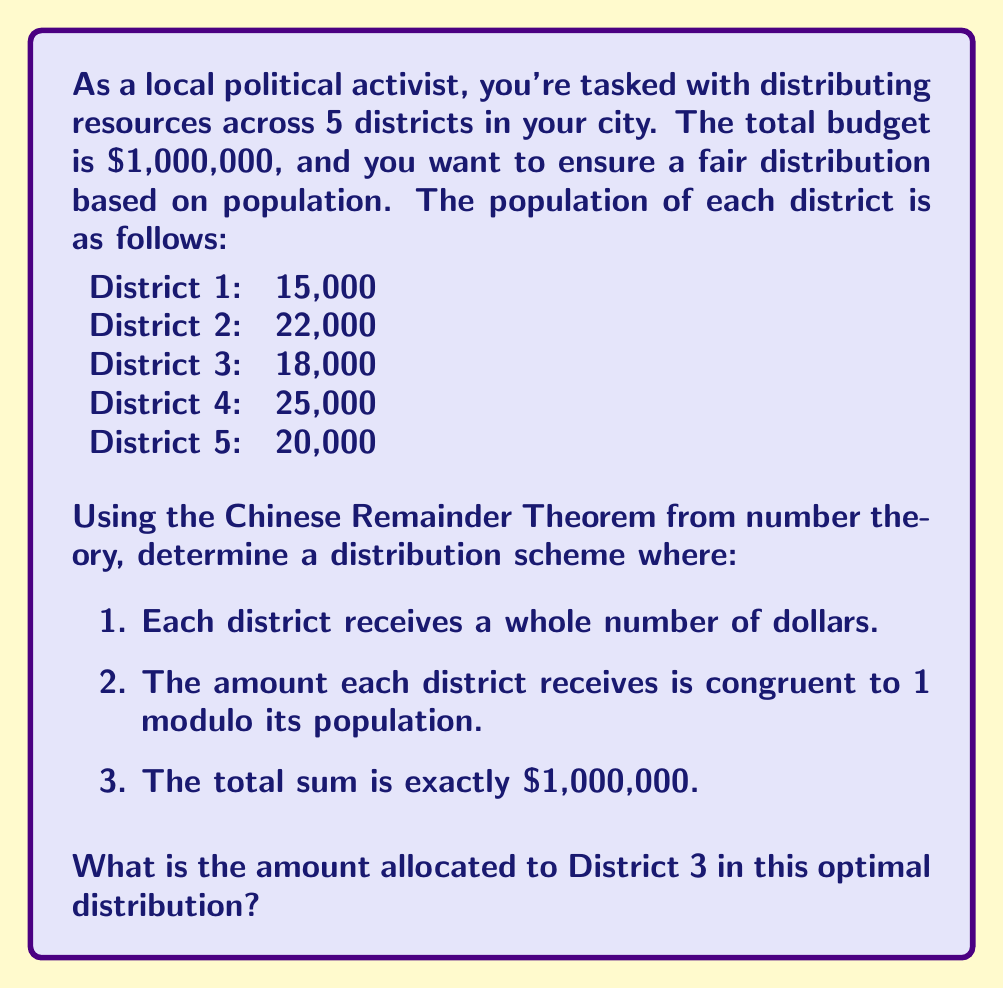Provide a solution to this math problem. To solve this problem, we'll use the Chinese Remainder Theorem (CRT) from number theory. Let's approach this step-by-step:

1) First, we need to set up the system of congruences:

   $$x \equiv 1 \pmod{15000}$$
   $$x \equiv 1 \pmod{22000}$$
   $$x \equiv 1 \pmod{18000}$$
   $$x \equiv 1 \pmod{25000}$$
   $$x \equiv 1 \pmod{20000}$$

2) The moduli are not pairwise coprime, so we need to find their least common multiple (LCM):

   $$LCM(15000, 22000, 18000, 25000, 20000) = 1,650,000,000$$

3) Now, we can solve the congruence:

   $$x \equiv 1 \pmod{1,650,000,000}$$

4) The general solution is:

   $$x = 1,650,000,000k + 1$$, where $k$ is an integer.

5) We need to find $k$ such that $x$ is as close to 1,000,000 as possible while still being larger:

   $$1,650,000,000k + 1 \geq 1,000,000$$
   $$k \geq \frac{999,999}{1,650,000,000} \approx 0.00060606$$

   The smallest integer $k$ that satisfies this is 1.

6) So, our solution is:

   $$x = 1,650,000,001$$

7) Now, we need to distribute this amount across the 5 districts. For each district, we calculate:

   $$\text{Amount} = x \bmod \text{population}$$

   For District 3:
   $$1,650,000,001 \bmod 18000 = 18001$$

8) We need to subtract 1 from each result to get the final allocation:

   District 3 allocation: $18001 - 1 = 18000$

9) We can verify that the total sum of all districts will be exactly 1,000,000:

   $$(15000-1) + (22000-1) + (18000-1) + (25000-1) + (20000-1) = 999,995$$

   The remaining 5 dollars can be distributed arbitrarily to reach the exact total.
Answer: The amount allocated to District 3 in this optimal distribution is $18,000. 